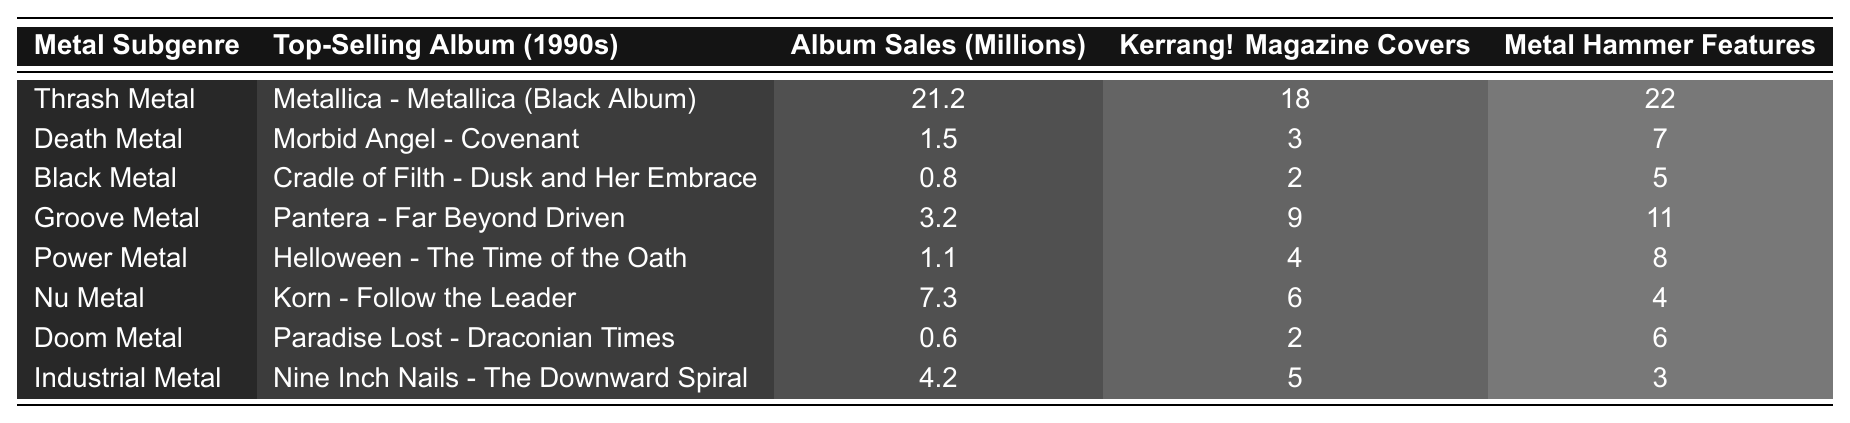What is the top-selling album in the Thrash Metal subgenre? The table lists "Metallica - Metallica (Black Album)" as the top-selling album under the Thrash Metal subgenre.
Answer: Metallica - Metallica (Black Album) How many magazine covers did Nu Metal receive in total? The table shows that Nu Metal received 6 Kerrang! Magazine Covers and 4 Metal Hammer Features. To find the total, we sum these values: 6 + 4 = 10.
Answer: 10 Is it true that Doom Metal had higher album sales than Black Metal? The album sales for Doom Metal are 0.6 million, while Black Metal had 0.8 million in sales. Since 0.6 is less than 0.8, the statement is false.
Answer: False Which metal subgenre had the highest number of Kerrang! Magazine Covers? By comparing the Kerrang! Magazine Covers data, Thrash Metal has the highest at 18 covers, which is more than any other subgenre in the table.
Answer: Thrash Metal What is the average album sales among all the metal subgenres listed? First, we sum the album sales: 21.2 + 1.5 + 0.8 + 3.2 + 1.1 + 7.3 + 0.6 + 4.2 = 39.9 million. Then, we divide by the number of subgenres, which is 8: 39.9 / 8 = 4.9875.
Answer: 4.99 How many more Metal Hammer Features did Groove Metal have compared to Death Metal? Groove Metal has 11 Metal Hammer Features and Death Metal has 7. The difference is 11 - 7 = 4.
Answer: 4 Which subgenre has the lowest album sales? Looking at the Album Sales column, Doom Metal has the lowest sales with 0.6 million.
Answer: Doom Metal What is the total number of magazine covers (Kerrang! and Metal Hammer) for Industrial Metal? Industrial Metal has 5 Kerrang! features and 3 Metal Hammer features. The sum of these values is 5 + 3 = 8.
Answer: 8 Which metal subgenre sees higher popularity in terms of magazine coverage, Death Metal or Black Metal? Death Metal has 3 covers from Kerrang! and 7 from Metal Hammer, summing to a total of 10. Black Metal has 2 from Kerrang! and 5 from Metal Hammer, summing to 7. Since 10 is greater than 7, Death Metal has higher coverage.
Answer: Death Metal What percentage of total album sales does the Nu Metal subgenre account for? Total album sales from the table are 39.9 million. Nu Metal sales are 7.3 million. The percentage is calculated as (7.3 / 39.9) * 100 ≈ 18.27%.
Answer: 18.27% 